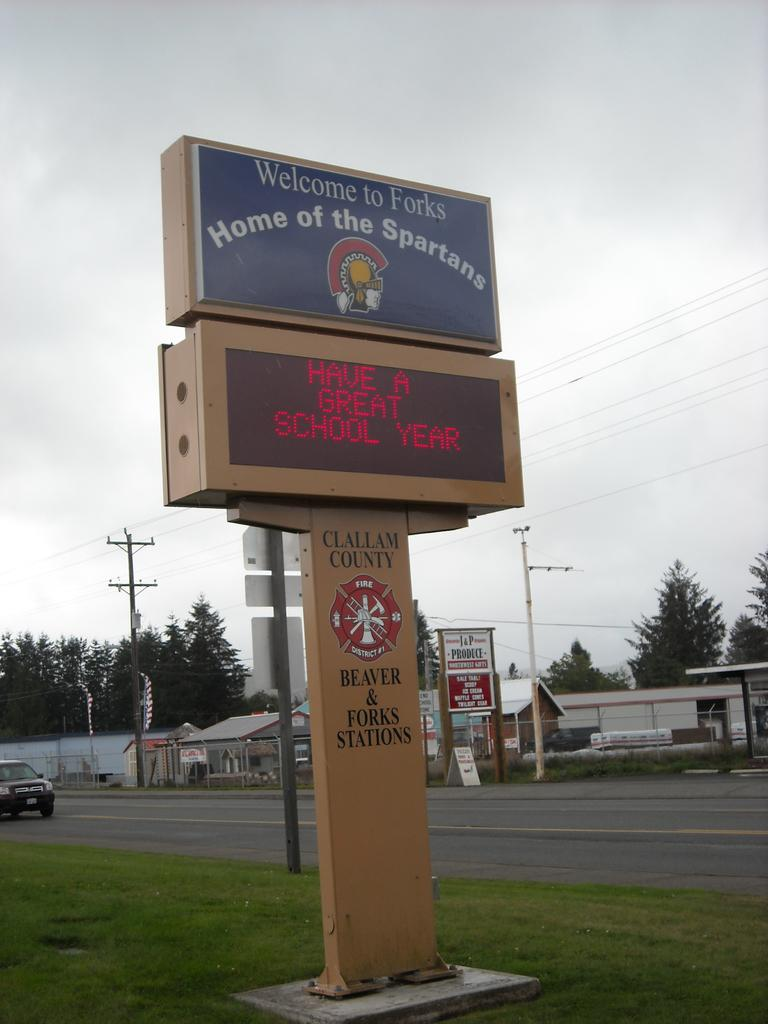<image>
Offer a succinct explanation of the picture presented. A sign on a patch of grass near a road reads Welcome to Fork Home of the Spartans Have a Great School Year. 